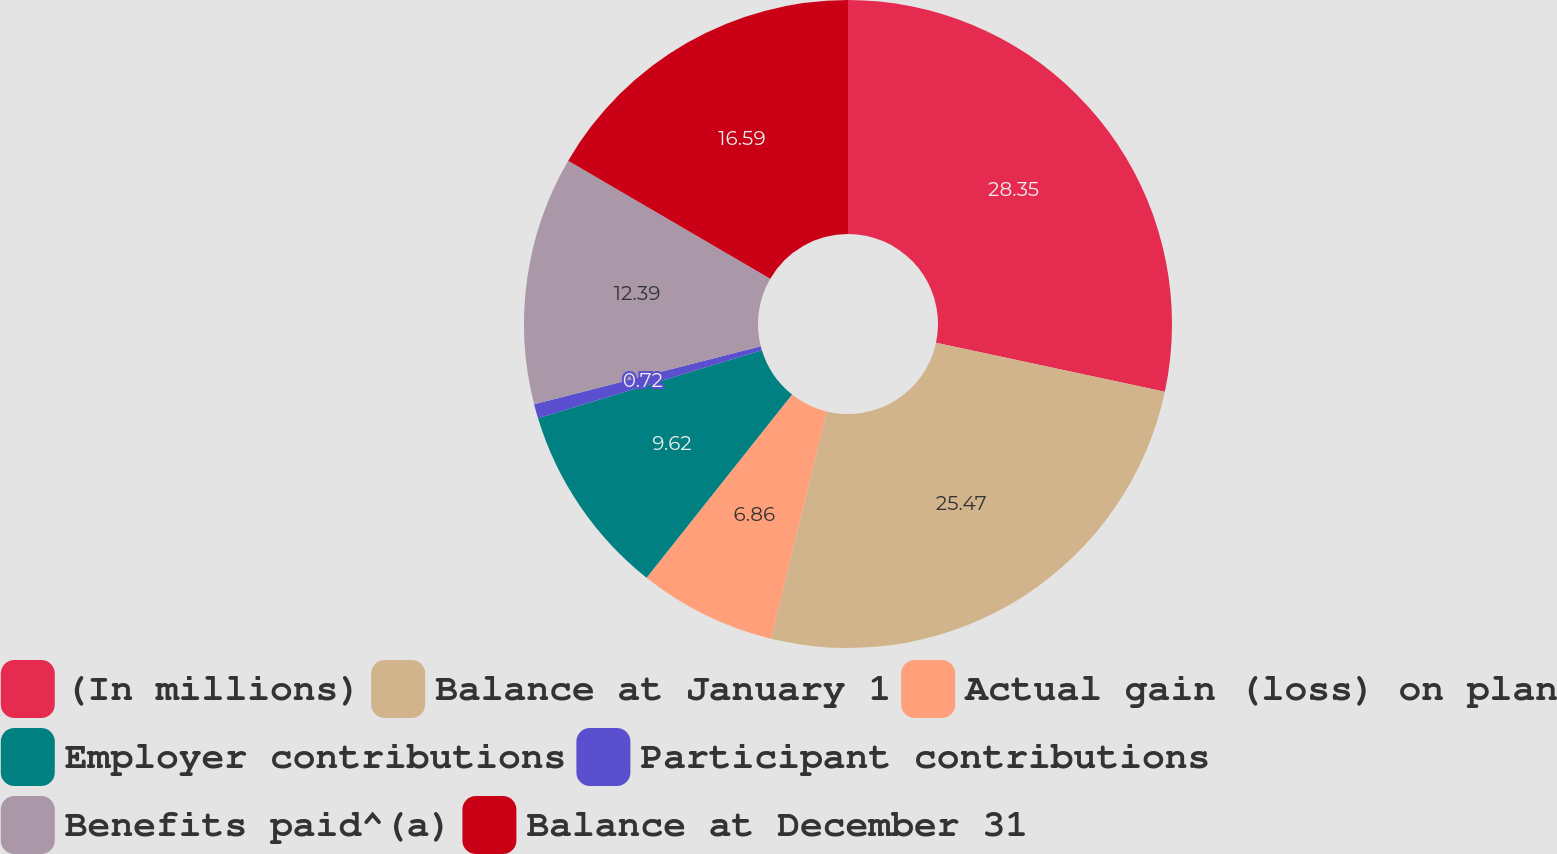<chart> <loc_0><loc_0><loc_500><loc_500><pie_chart><fcel>(In millions)<fcel>Balance at January 1<fcel>Actual gain (loss) on plan<fcel>Employer contributions<fcel>Participant contributions<fcel>Benefits paid^(a)<fcel>Balance at December 31<nl><fcel>28.35%<fcel>25.47%<fcel>6.86%<fcel>9.62%<fcel>0.72%<fcel>12.39%<fcel>16.59%<nl></chart> 